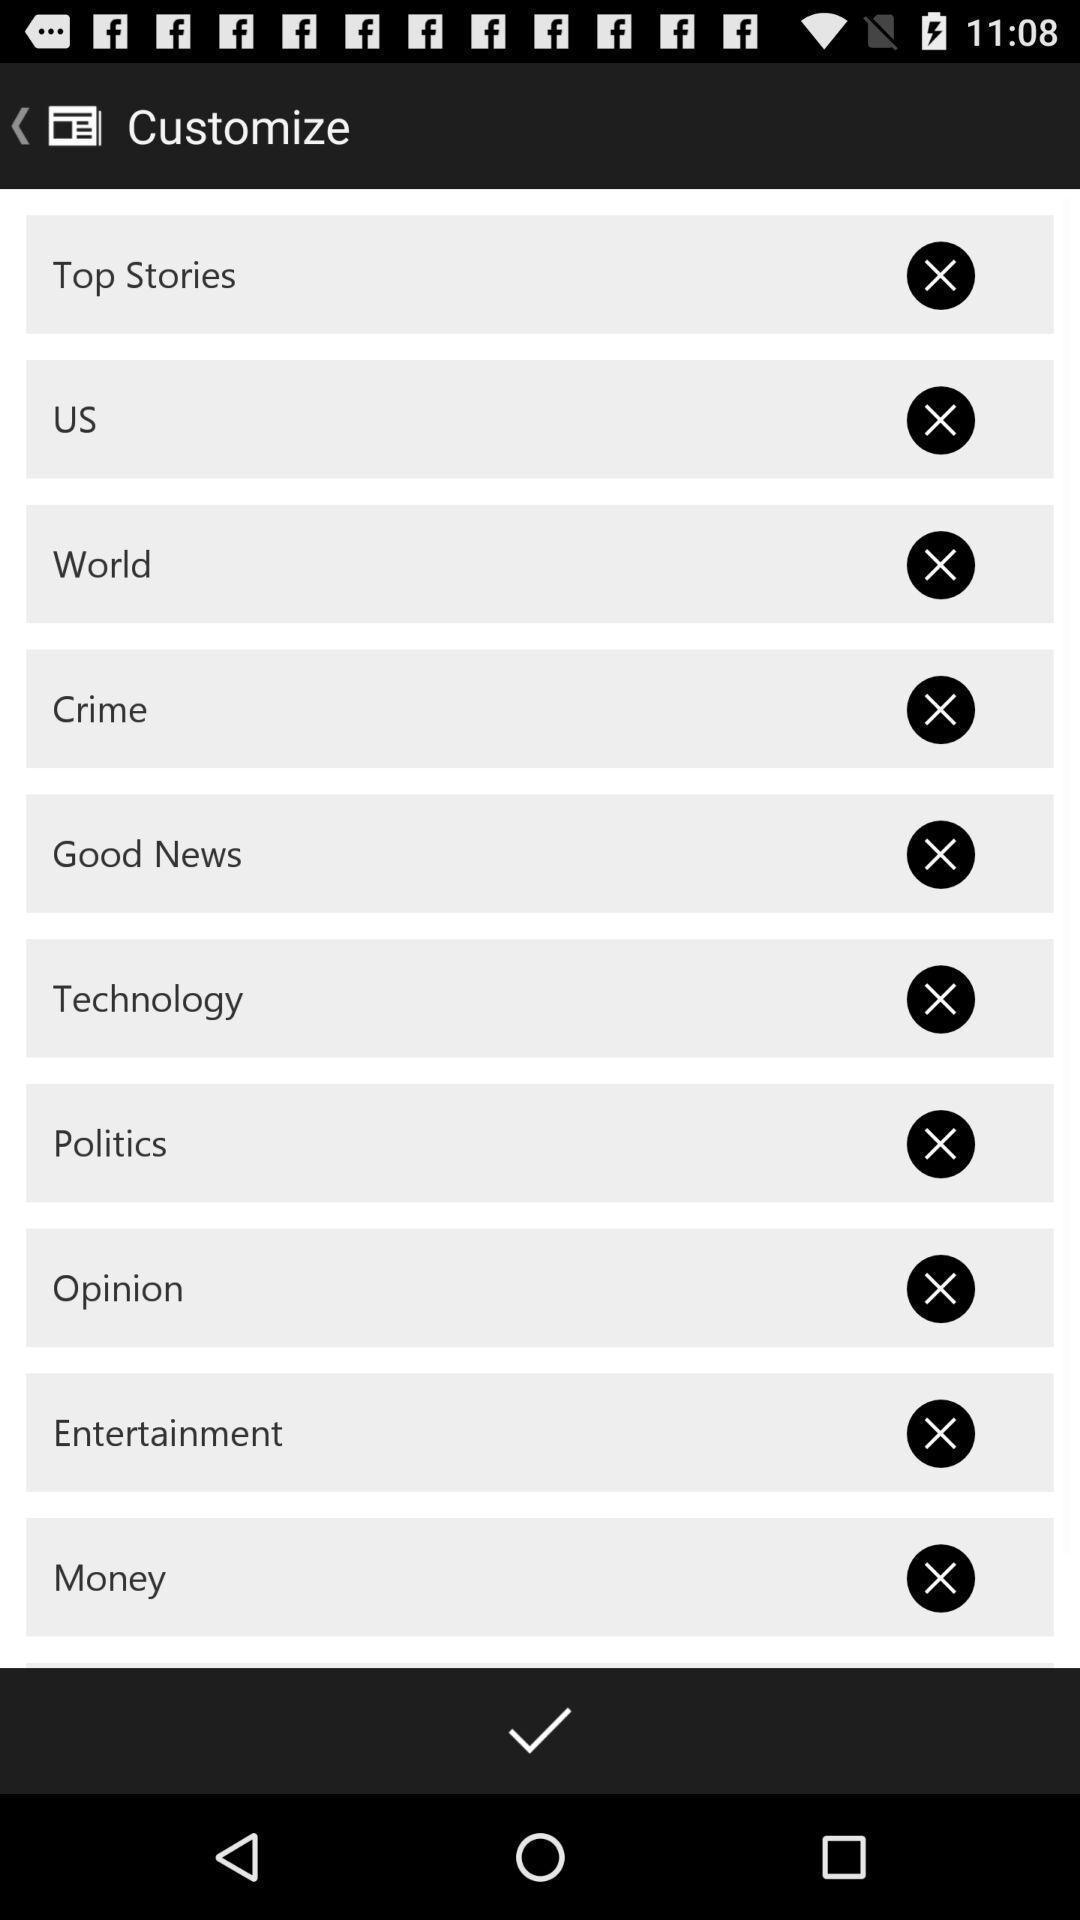What can you discern from this picture? Page displays customize list in app. 